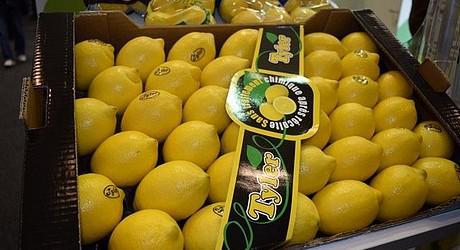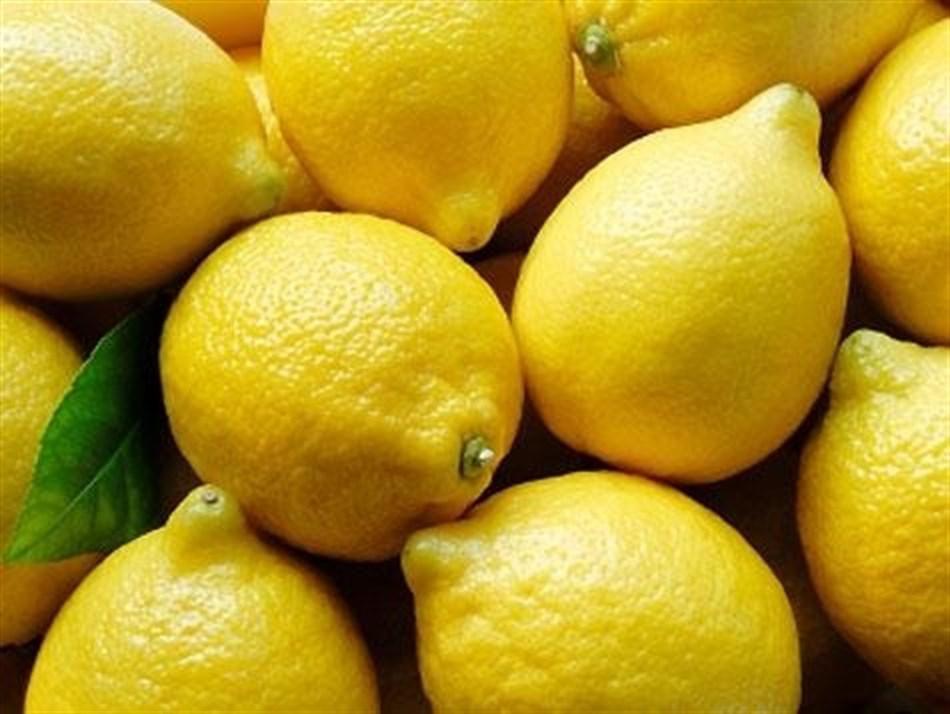The first image is the image on the left, the second image is the image on the right. Evaluate the accuracy of this statement regarding the images: "Some of the lemons are packaged.". Is it true? Answer yes or no. Yes. 